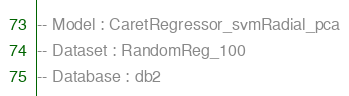Convert code to text. <code><loc_0><loc_0><loc_500><loc_500><_SQL_>-- Model : CaretRegressor_svmRadial_pca
-- Dataset : RandomReg_100
-- Database : db2

</code> 